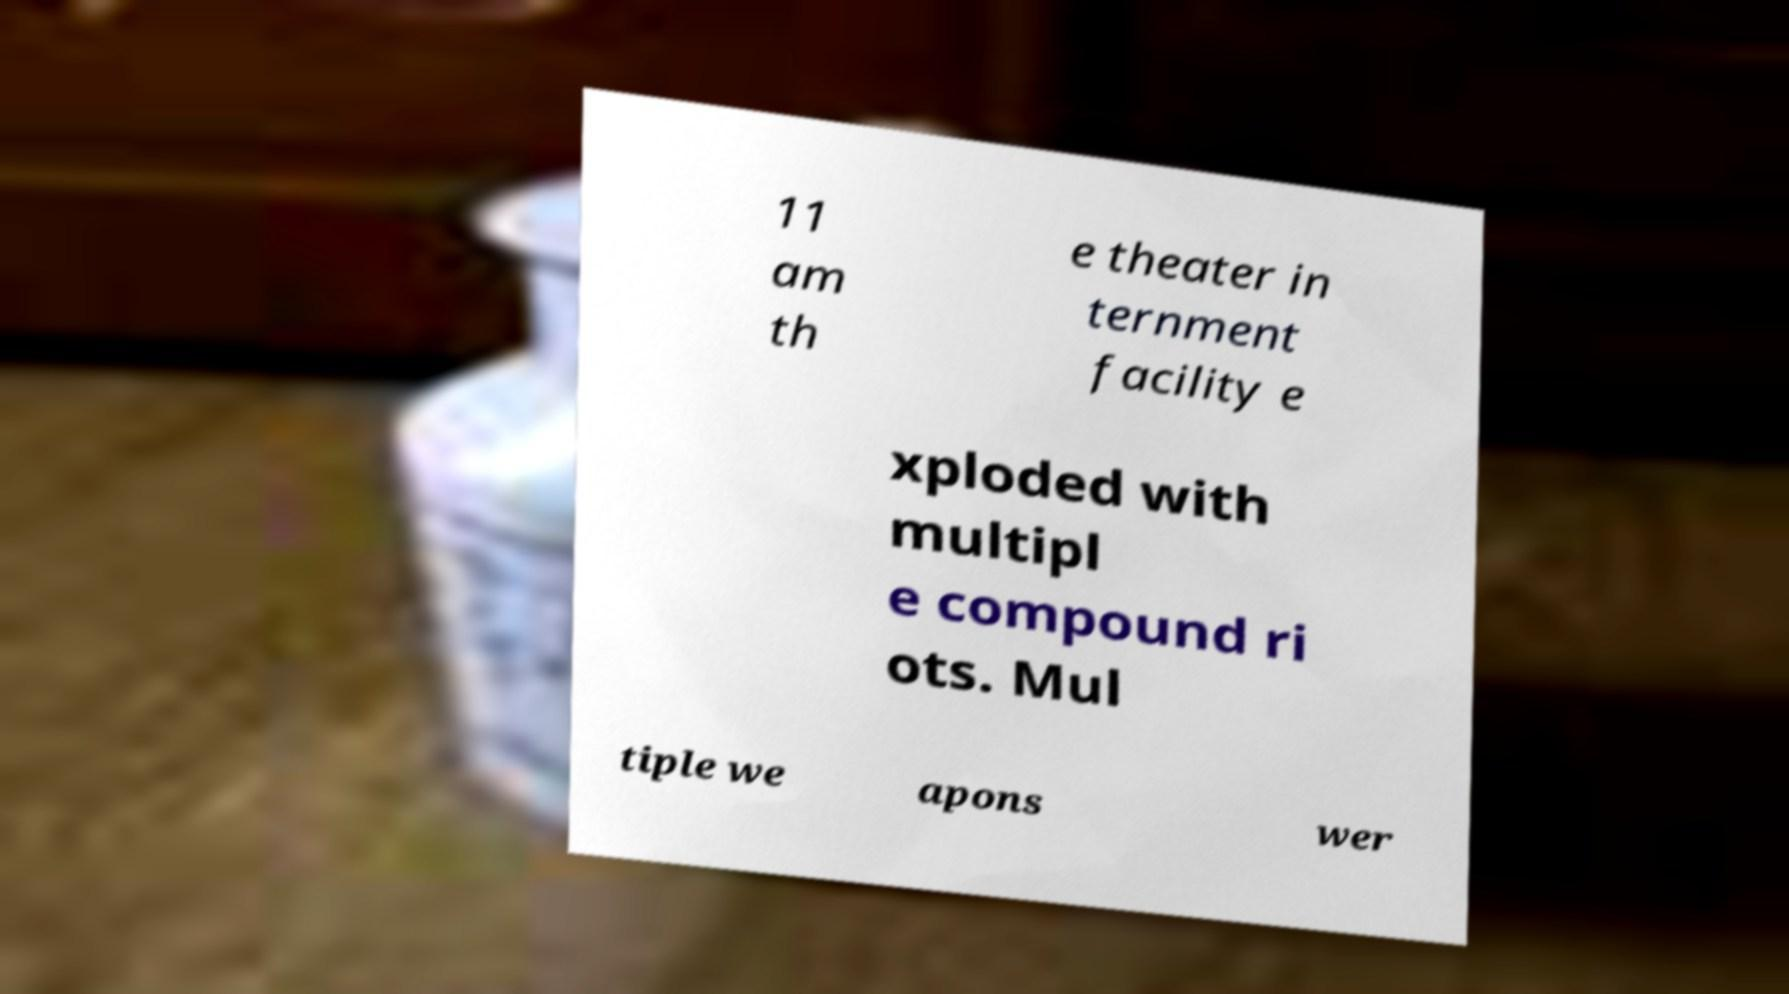Please identify and transcribe the text found in this image. 11 am th e theater in ternment facility e xploded with multipl e compound ri ots. Mul tiple we apons wer 